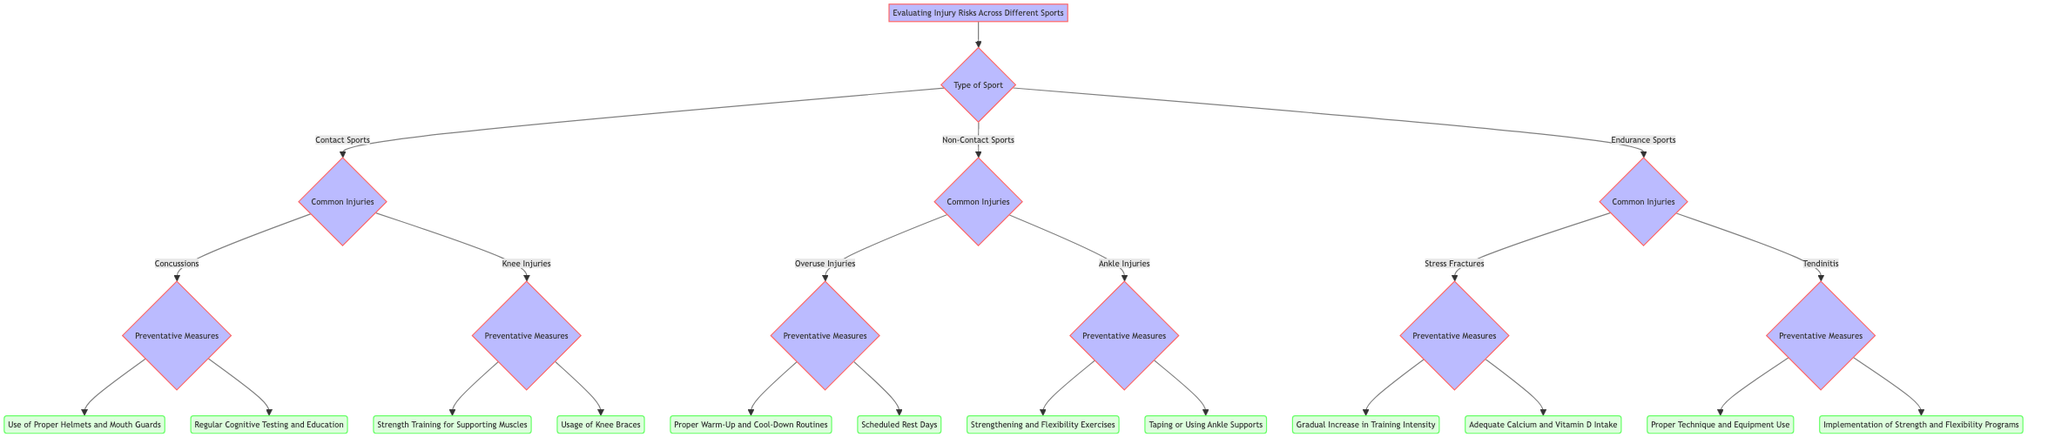What types of sports are evaluated in the diagram? The diagram presents three types of sports at the first decision node: Contact Sports, Non-Contact Sports, and Endurance Sports.
Answer: Contact Sports, Non-Contact Sports, Endurance Sports How many common injuries are listed for Endurance Sports? In the Endurance Sports section, there are two common injuries listed: Stress Fractures and Tendinitis.
Answer: 2 What preventative measures are recommended for Concussions? For Concussions, two preventative measures are provided: Use of Proper Helmets and Mouth Guards, and Regular Cognitive Testing and Education. Both options provide different ways to reduce the risk of concussions.
Answer: Use of Proper Helmets and Mouth Guards, Regular Cognitive Testing and Education What preventative measures are associated with Knee Injuries? Knee Injuries have two preventative measures listed: Strength Training for Supporting Muscles and Usage of Knee Braces. This indicates the importance of both strength training and protective devices in prevention.
Answer: Strength Training for Supporting Muscles, Usage of Knee Braces Which sport type is associated with Overuse Injuries? Overuse Injuries are specifically linked to Non-Contact Sports according to the diagram, which highlights the common injuries related to that sport category.
Answer: Non-Contact Sports What is the immediate next question after selecting Ankle Injuries? After choosing Ankle Injuries, the next question asked is about Preventative Measures pertaining to those injuries, signifying how to best prevent such occurrences.
Answer: Preventative Measures How many options are there for Preventative Measures under Stress Fractures? For Stress Fractures, there are two recommended preventative measures shown: Gradual Increase in Training Intensity and Adequate Calcium and Vitamin D Intake, indicating multiple strategies for prevention.
Answer: 2 What type of sport includes Concussions as a common injury? Concussions are categorized under Contact Sports, highlighting the risks associated with physical contact in those sports.
Answer: Contact Sports 